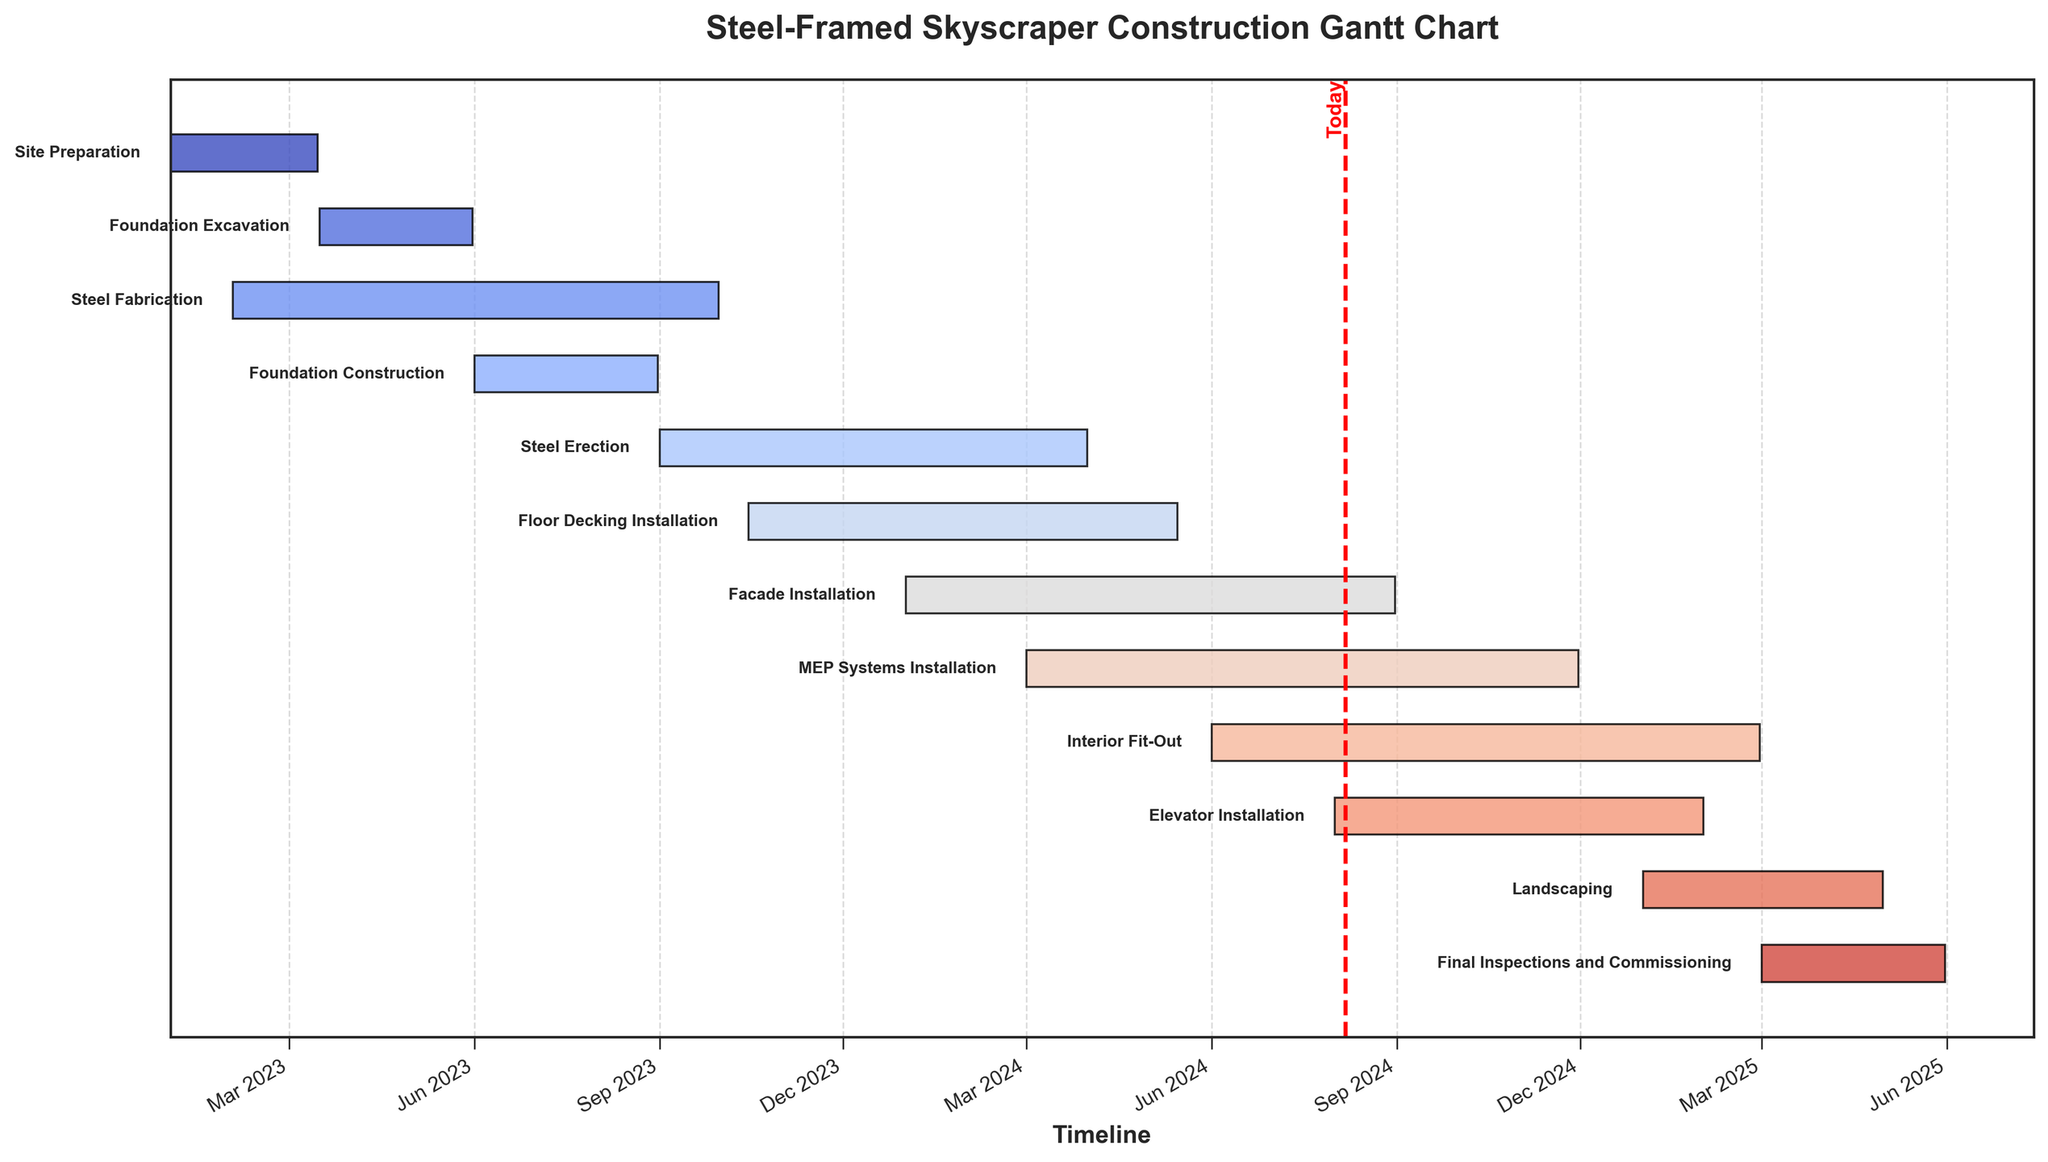What's the total duration of the "Steel Erection" phase? To find the duration, calculate the difference between the start and end dates of the "Steel Erection" phase. It starts on 2023-09-01 and ends on 2024-03-31. The duration in days is (2024-03-31 - 2023-09-01).
Answer: 212 days How many tasks are planned to start in January 2024? By checking the start dates listed, we find that only "Facade Installation" is planned to start in January 2024.
Answer: 1 task Which two tasks have overlapping durations between March 2024 and May 2024? Looking at the dates, "MEP Systems Installation" overlaps with "Facade Installation" during March 2024 to May 2024.
Answer: MEP Systems Installation and Facade Installation Which phase has the shortest duration? To determine the shortest duration, compare the number of days for each task. "Final Inspections and Commissioning" runs for 92 days from 2025-03-01 to 2025-05-31, which is the shortest.
Answer: Final Inspections and Commissioning When does the "Interior Fit-Out" phase end? Check the end date for the "Interior Fit-Out" phase. This phase ends on 2025-02-28.
Answer: 2025-02-28 Which tasks are ongoing if today is 2024-04-01? Compare today's date to the intervals of each task. The tasks ongoing are "Steel Erection," "Floor Decking Installation," "Facade Installation," and "MEP Systems Installation."
Answer: Steel Erection, Floor Decking Installation, Facade Installation, MEP Systems Installation What is the duration of the entire construction project? Calculate the duration from the start of the first task "Site Preparation" (2023-01-01) to the end of the last task "Final Inspections and Commissioning" (2025-05-31). The duration is (2025-05-31 - 2023-01-01).
Answer: 881 days Which two windows have the most overlap? To find this, calculate the intersection period between every pair of tasks and find the one with the highest overlap in days. "Steel Fabrication" and "Foundation Construction" overlap for (2023-06-01 to 2023-08-31), which is 92 days.
Answer: Steel Fabrication and Foundation Construction What is the end date of the last task in 2024? The last task ending in 2024 is "Elevator Installation," which ends on 2025-01-31.
Answer: 2025-01-31 